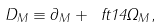Convert formula to latex. <formula><loc_0><loc_0><loc_500><loc_500>\ D _ { M } \equiv \partial _ { M } + \ f t 1 4 \Omega _ { M } ,</formula> 